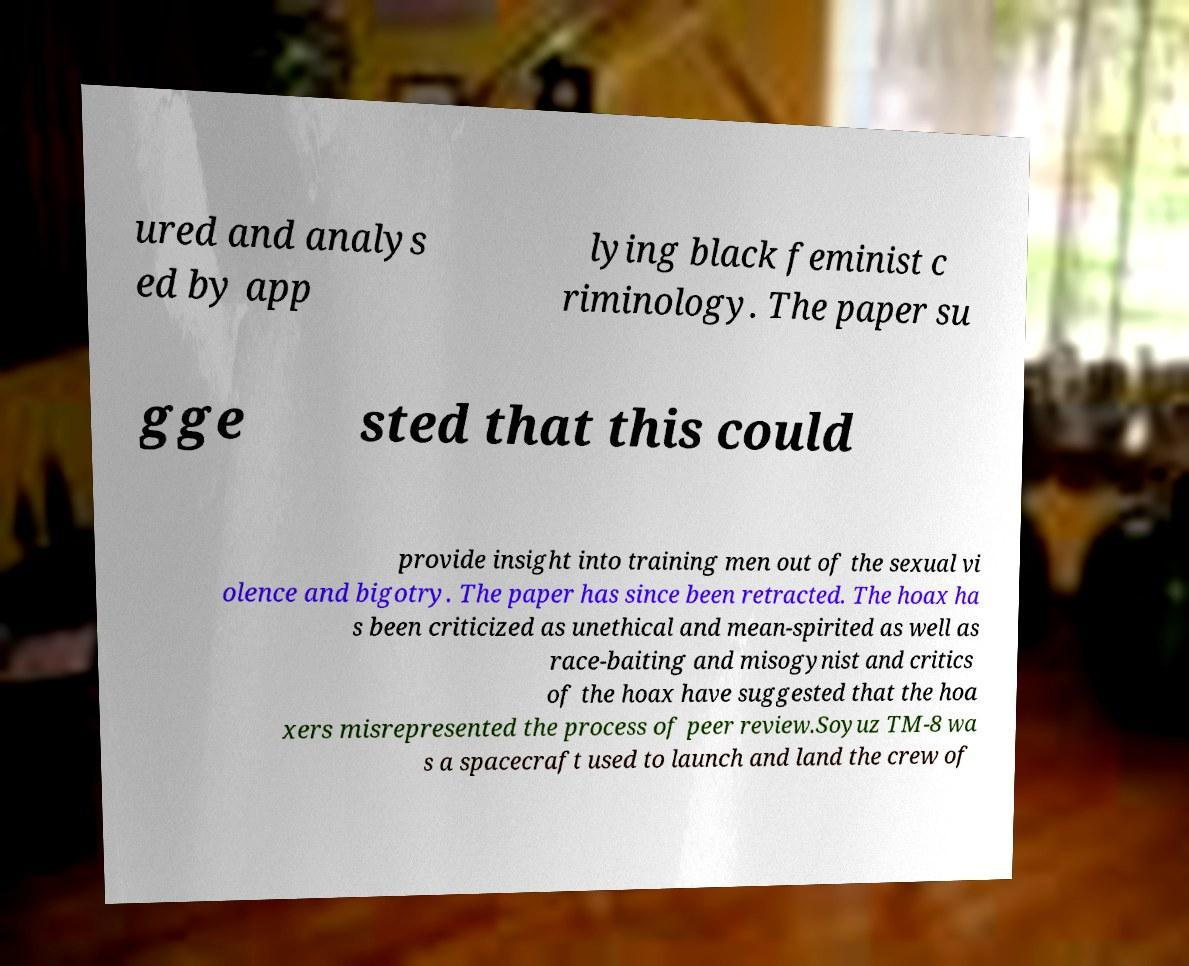Can you read and provide the text displayed in the image?This photo seems to have some interesting text. Can you extract and type it out for me? ured and analys ed by app lying black feminist c riminology. The paper su gge sted that this could provide insight into training men out of the sexual vi olence and bigotry. The paper has since been retracted. The hoax ha s been criticized as unethical and mean-spirited as well as race-baiting and misogynist and critics of the hoax have suggested that the hoa xers misrepresented the process of peer review.Soyuz TM-8 wa s a spacecraft used to launch and land the crew of 